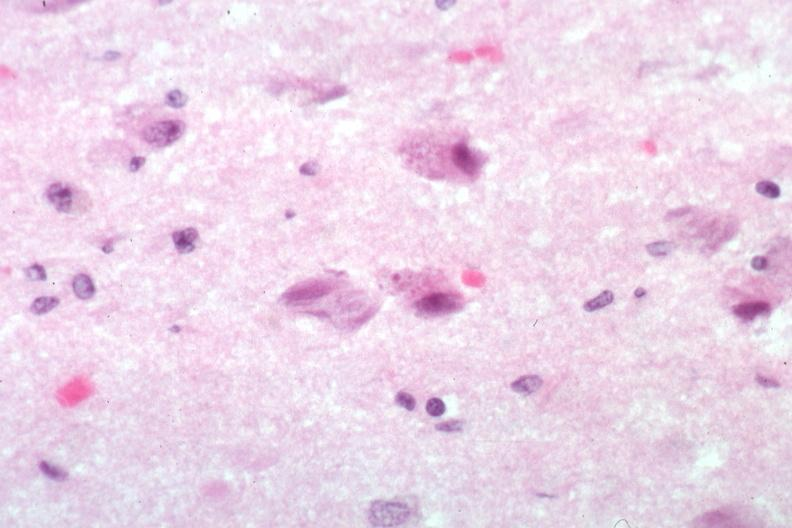s brain present?
Answer the question using a single word or phrase. Yes 